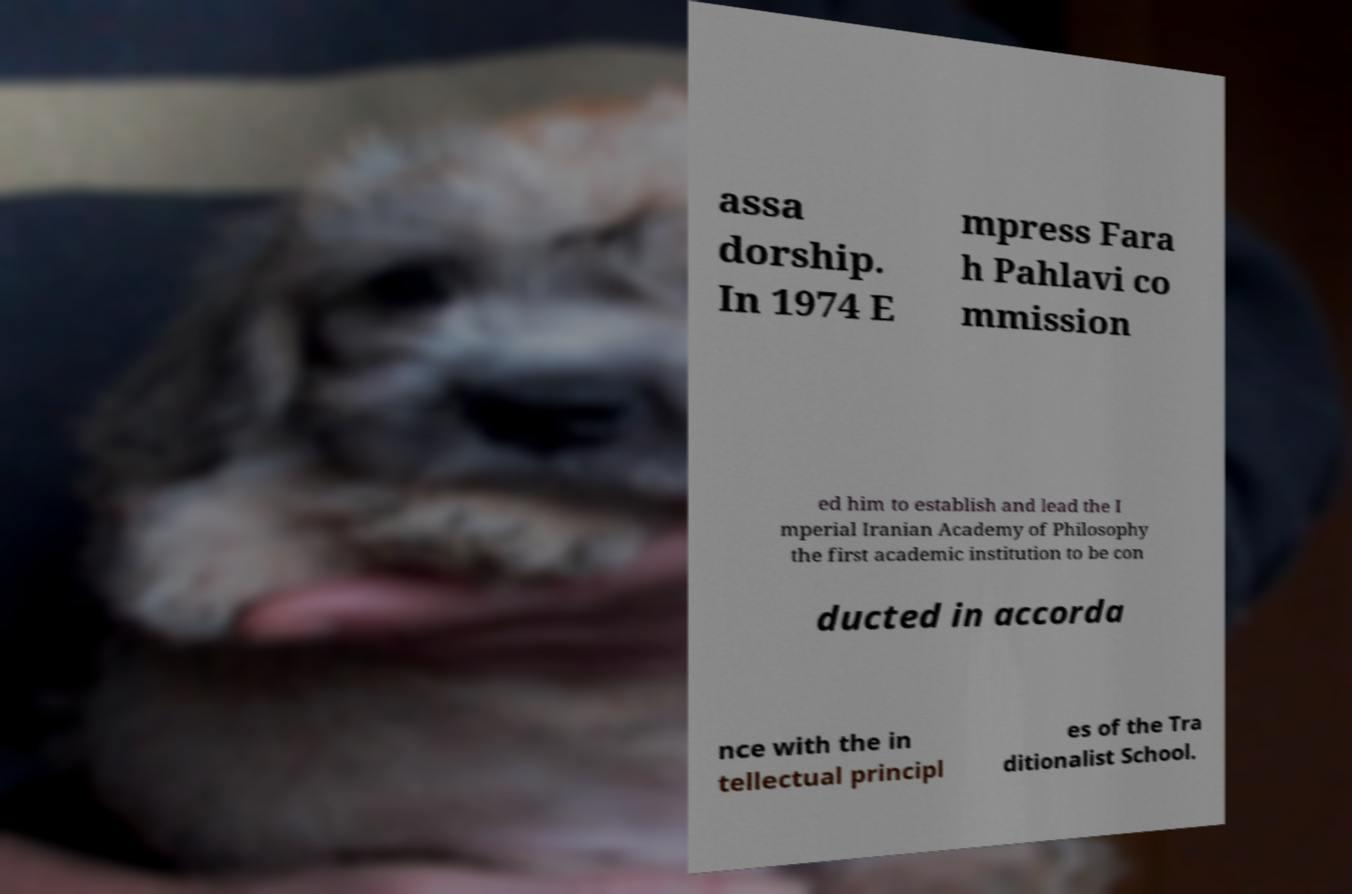Could you assist in decoding the text presented in this image and type it out clearly? assa dorship. In 1974 E mpress Fara h Pahlavi co mmission ed him to establish and lead the I mperial Iranian Academy of Philosophy the first academic institution to be con ducted in accorda nce with the in tellectual principl es of the Tra ditionalist School. 